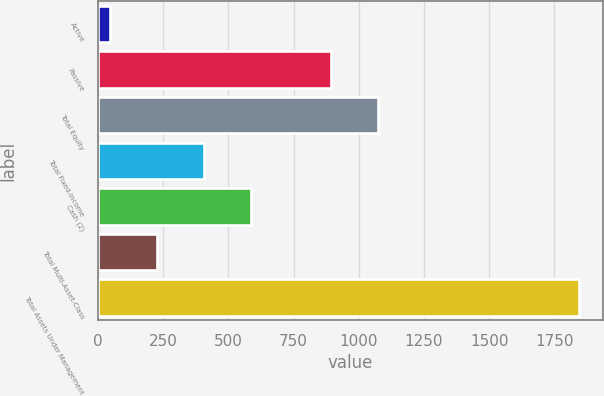Convert chart to OTSL. <chart><loc_0><loc_0><loc_500><loc_500><bar_chart><fcel>Active<fcel>Passive<fcel>Total Equity<fcel>Total Fixed-Income<fcel>Cash (2)<fcel>Total Multi-Asset-Class<fcel>Total Assets Under Management<nl><fcel>46<fcel>893<fcel>1072.9<fcel>405.8<fcel>585.7<fcel>225.9<fcel>1845<nl></chart> 